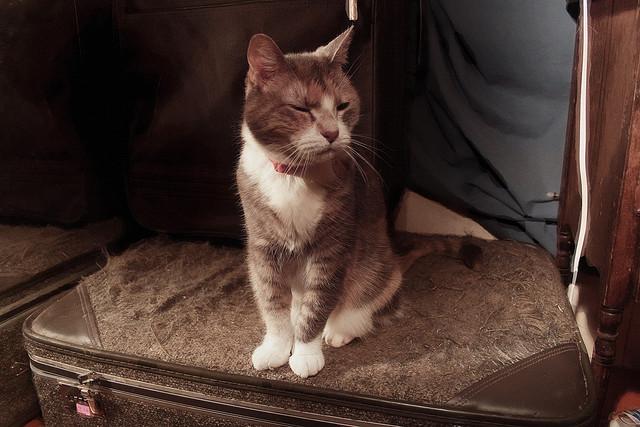Where is a suitcase?
Quick response, please. Under cat. Is the cat on a chair?
Short answer required. No. What color is the cat?
Short answer required. Gray and white. 